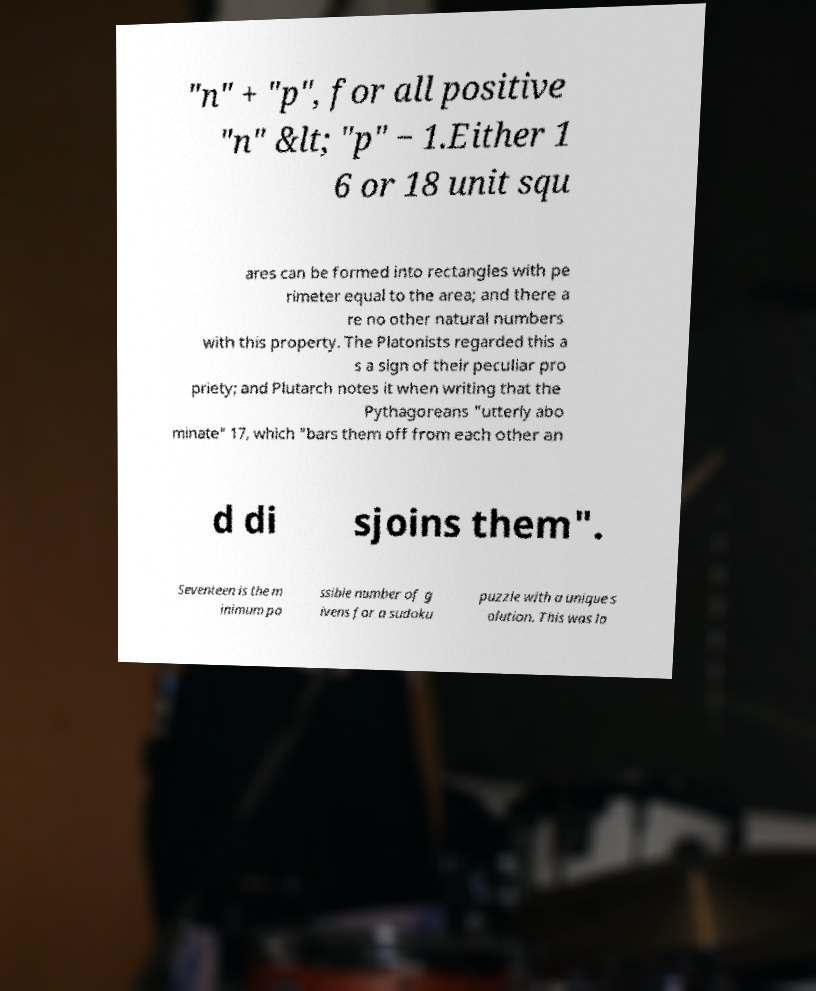I need the written content from this picture converted into text. Can you do that? "n" + "p", for all positive "n" &lt; "p" − 1.Either 1 6 or 18 unit squ ares can be formed into rectangles with pe rimeter equal to the area; and there a re no other natural numbers with this property. The Platonists regarded this a s a sign of their peculiar pro priety; and Plutarch notes it when writing that the Pythagoreans "utterly abo minate" 17, which "bars them off from each other an d di sjoins them". Seventeen is the m inimum po ssible number of g ivens for a sudoku puzzle with a unique s olution. This was lo 